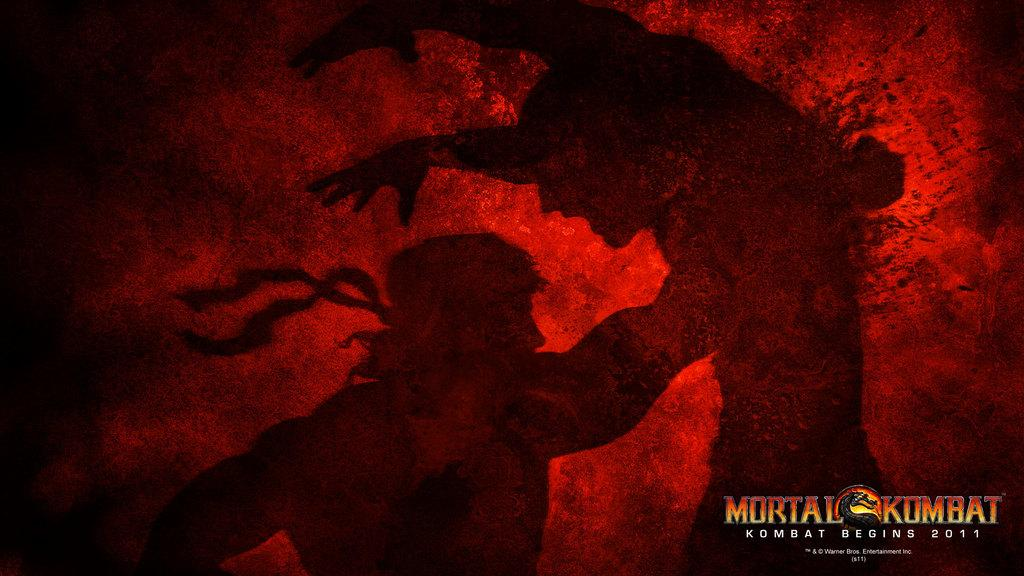<image>
Create a compact narrative representing the image presented. a red and black image portraying the movie mortal kombat 